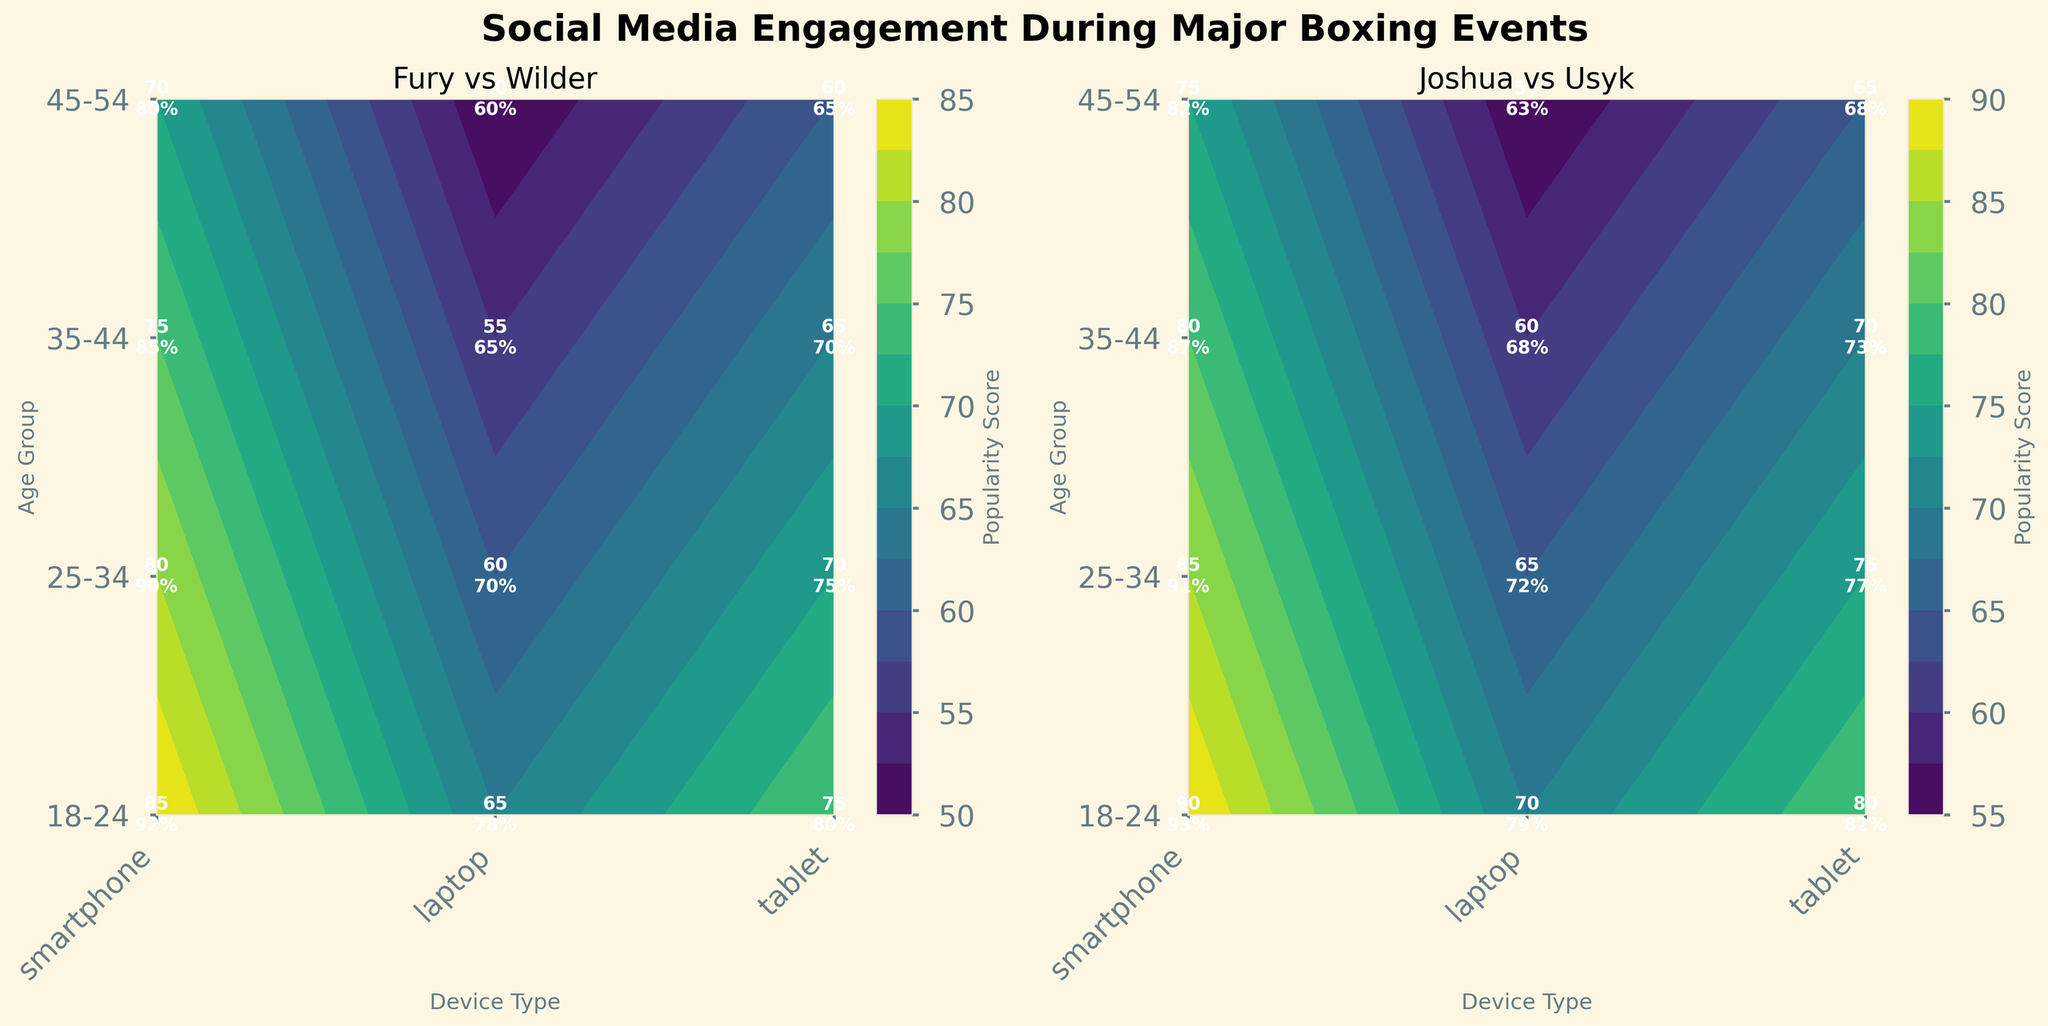What is the title of the figure? The title of the figure is displayed prominently at the top. It reads "Social Media Engagement During Major Boxing Events".
Answer: Social Media Engagement During Major Boxing Events Which device type has the highest popularity score for the 18-24 age group during Joshua vs Usyk? For the event "Joshua vs Usyk", in the 18-24 age group, the highest popularity score can be seen under the "smartphone" row.
Answer: smartphone What's the average popularity score for the 25-34 age group across all device types during the Fury vs Wilder event? The popularity scores for the 25-34 age group during the Fury vs Wilder event are 80 (smartphone), 60 (laptop), and 70 (tablet). Summing these up gives 210, and the average is 210/3 = 70.
Answer: 70 How do the engagement rates of the 35-44 age group using tablets compare between the two events? The engagement rates for the 35-44 age group using tablets are 70% for Fury vs Wilder and 73% for Joshua vs Usyk.
Answer: Lower for Fury vs Wilder For the Fury vs Wilder event, which age group and device type combination has the lowest engagement rate? In the Fury vs Wilder event, the least engaging combination is the 45-54 age group using laptops with an engagement rate of 60%.
Answer: 45-54 and laptop What colors are used to depict the popularity scores in the contour plots? The contour plots use shades of a gradient, specifically in the viridis color map, to represent the popularity scores.
Answer: Shades of viridis Which event shows higher overall popularity scores on average across all age groups and device types? Calculating the average popularity score for both events: 
   - Fury vs Wilder: (85+65+75+80+60+70+75+55+65+70+50+60) / 12 ≈ 67.5
   - Joshua vs Usyk: (90+70+80+85+65+75+80+60+70+75+55+65) / 12 ≈ 71.25
   Joshua vs Usyk has a higher average popularity score.
Answer: Joshua vs Usyk Compare the engagement rates for smartphones in the 25-34 age group between the two events. For the 25-34 age group, the engagement rates for smartphones are 90% for Fury vs Wilder and 91% for Joshua vs Usyk; thus, the engagement rate for Joshua vs Usyk is slightly higher.
Answer: Higher for Joshua vs Usyk How does the popularity score trend with age groups for the laptop device type in the Joshua vs Usyk event? In the Joshua vs Usyk event for laptops, popularity scores trend as follows: 18-24 age group has 70, 25-34 has 65, 35-44 has 60, and 45-54 has 55. This shows a decreasing trend with increasing age.
Answer: Decreasing with age What is the highest engagement rate across all age groups and device types for the Fury vs Wilder event? For the Fury vs Wilder event, the highest engagement rate is found in the 18-24 age group using smartphones at 92%.
Answer: 92% 